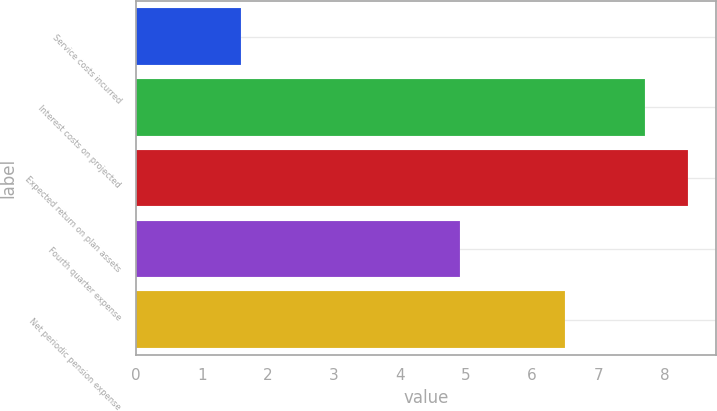<chart> <loc_0><loc_0><loc_500><loc_500><bar_chart><fcel>Service costs incurred<fcel>Interest costs on projected<fcel>Expected return on plan assets<fcel>Fourth quarter expense<fcel>Net periodic pension expense<nl><fcel>1.6<fcel>7.7<fcel>8.36<fcel>4.9<fcel>6.5<nl></chart> 